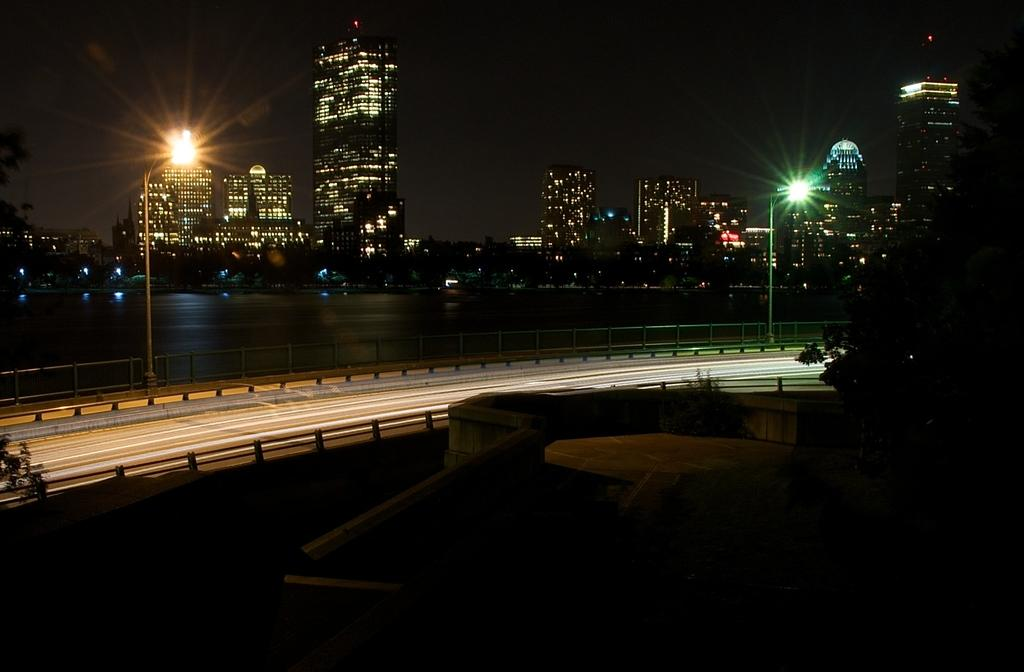What is the main feature of the image? There is a road in the image. Are there any structures near the road? Yes, there are two street lights beside the road. What can be seen in the right corner of the image? There is a tree in the right corner of the image. What is visible in the background of the image? There are buildings and water visible in the background of the image. What type of pear is hanging from the tree in the image? There is no pear present in the image; it features a tree without any fruit. What type of metal is used to construct the buildings in the background? The image does not provide information about the materials used to construct the buildings in the background. 